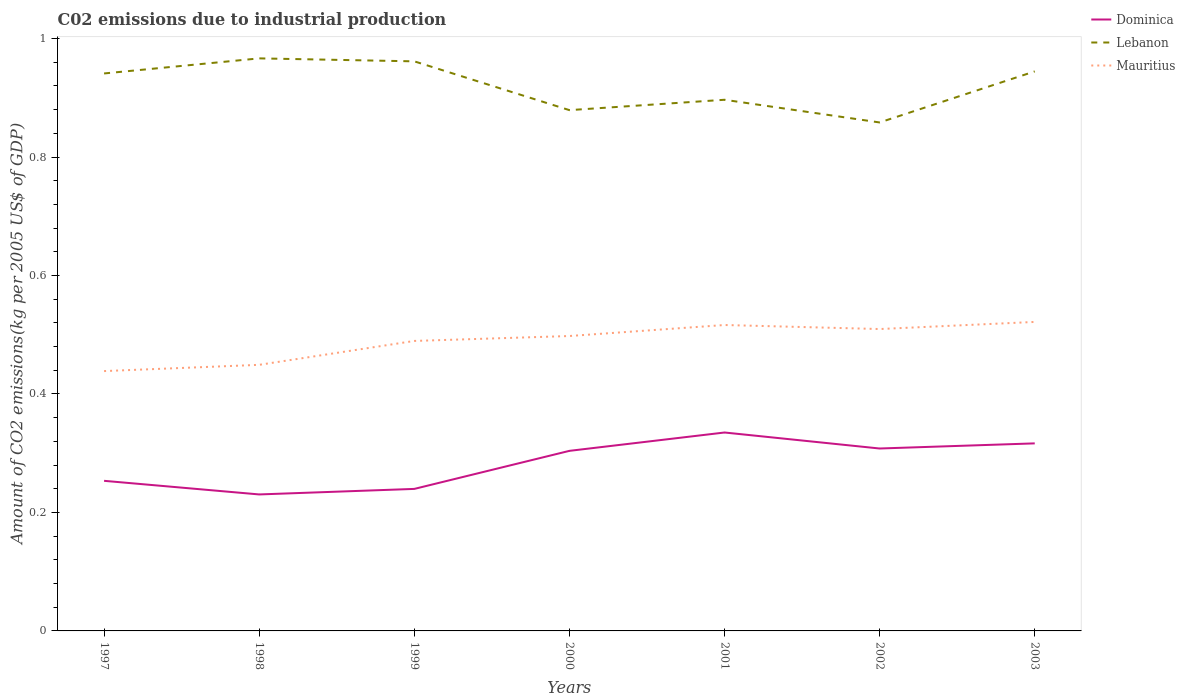How many different coloured lines are there?
Your answer should be compact. 3. Across all years, what is the maximum amount of CO2 emitted due to industrial production in Lebanon?
Ensure brevity in your answer.  0.86. In which year was the amount of CO2 emitted due to industrial production in Lebanon maximum?
Your answer should be compact. 2002. What is the total amount of CO2 emitted due to industrial production in Dominica in the graph?
Give a very brief answer. -0.05. What is the difference between the highest and the second highest amount of CO2 emitted due to industrial production in Mauritius?
Ensure brevity in your answer.  0.08. How many years are there in the graph?
Provide a short and direct response. 7. Are the values on the major ticks of Y-axis written in scientific E-notation?
Your answer should be compact. No. Does the graph contain grids?
Make the answer very short. No. Where does the legend appear in the graph?
Ensure brevity in your answer.  Top right. How are the legend labels stacked?
Provide a short and direct response. Vertical. What is the title of the graph?
Provide a short and direct response. C02 emissions due to industrial production. What is the label or title of the Y-axis?
Your answer should be compact. Amount of CO2 emissions(kg per 2005 US$ of GDP). What is the Amount of CO2 emissions(kg per 2005 US$ of GDP) of Dominica in 1997?
Your answer should be compact. 0.25. What is the Amount of CO2 emissions(kg per 2005 US$ of GDP) in Lebanon in 1997?
Keep it short and to the point. 0.94. What is the Amount of CO2 emissions(kg per 2005 US$ of GDP) of Mauritius in 1997?
Offer a very short reply. 0.44. What is the Amount of CO2 emissions(kg per 2005 US$ of GDP) in Dominica in 1998?
Your answer should be very brief. 0.23. What is the Amount of CO2 emissions(kg per 2005 US$ of GDP) of Lebanon in 1998?
Offer a terse response. 0.97. What is the Amount of CO2 emissions(kg per 2005 US$ of GDP) of Mauritius in 1998?
Offer a very short reply. 0.45. What is the Amount of CO2 emissions(kg per 2005 US$ of GDP) of Dominica in 1999?
Your response must be concise. 0.24. What is the Amount of CO2 emissions(kg per 2005 US$ of GDP) in Lebanon in 1999?
Your answer should be compact. 0.96. What is the Amount of CO2 emissions(kg per 2005 US$ of GDP) in Mauritius in 1999?
Give a very brief answer. 0.49. What is the Amount of CO2 emissions(kg per 2005 US$ of GDP) of Dominica in 2000?
Ensure brevity in your answer.  0.3. What is the Amount of CO2 emissions(kg per 2005 US$ of GDP) in Lebanon in 2000?
Your answer should be compact. 0.88. What is the Amount of CO2 emissions(kg per 2005 US$ of GDP) in Mauritius in 2000?
Your answer should be very brief. 0.5. What is the Amount of CO2 emissions(kg per 2005 US$ of GDP) in Dominica in 2001?
Your response must be concise. 0.33. What is the Amount of CO2 emissions(kg per 2005 US$ of GDP) of Lebanon in 2001?
Make the answer very short. 0.9. What is the Amount of CO2 emissions(kg per 2005 US$ of GDP) of Mauritius in 2001?
Provide a short and direct response. 0.52. What is the Amount of CO2 emissions(kg per 2005 US$ of GDP) of Dominica in 2002?
Ensure brevity in your answer.  0.31. What is the Amount of CO2 emissions(kg per 2005 US$ of GDP) in Lebanon in 2002?
Your response must be concise. 0.86. What is the Amount of CO2 emissions(kg per 2005 US$ of GDP) in Mauritius in 2002?
Give a very brief answer. 0.51. What is the Amount of CO2 emissions(kg per 2005 US$ of GDP) in Dominica in 2003?
Your answer should be compact. 0.32. What is the Amount of CO2 emissions(kg per 2005 US$ of GDP) in Lebanon in 2003?
Provide a short and direct response. 0.94. What is the Amount of CO2 emissions(kg per 2005 US$ of GDP) of Mauritius in 2003?
Provide a succinct answer. 0.52. Across all years, what is the maximum Amount of CO2 emissions(kg per 2005 US$ of GDP) in Dominica?
Provide a succinct answer. 0.33. Across all years, what is the maximum Amount of CO2 emissions(kg per 2005 US$ of GDP) in Lebanon?
Your answer should be compact. 0.97. Across all years, what is the maximum Amount of CO2 emissions(kg per 2005 US$ of GDP) of Mauritius?
Ensure brevity in your answer.  0.52. Across all years, what is the minimum Amount of CO2 emissions(kg per 2005 US$ of GDP) of Dominica?
Keep it short and to the point. 0.23. Across all years, what is the minimum Amount of CO2 emissions(kg per 2005 US$ of GDP) in Lebanon?
Keep it short and to the point. 0.86. Across all years, what is the minimum Amount of CO2 emissions(kg per 2005 US$ of GDP) of Mauritius?
Offer a very short reply. 0.44. What is the total Amount of CO2 emissions(kg per 2005 US$ of GDP) in Dominica in the graph?
Keep it short and to the point. 1.99. What is the total Amount of CO2 emissions(kg per 2005 US$ of GDP) of Lebanon in the graph?
Give a very brief answer. 6.45. What is the total Amount of CO2 emissions(kg per 2005 US$ of GDP) of Mauritius in the graph?
Offer a terse response. 3.42. What is the difference between the Amount of CO2 emissions(kg per 2005 US$ of GDP) in Dominica in 1997 and that in 1998?
Your response must be concise. 0.02. What is the difference between the Amount of CO2 emissions(kg per 2005 US$ of GDP) in Lebanon in 1997 and that in 1998?
Make the answer very short. -0.03. What is the difference between the Amount of CO2 emissions(kg per 2005 US$ of GDP) in Mauritius in 1997 and that in 1998?
Your answer should be very brief. -0.01. What is the difference between the Amount of CO2 emissions(kg per 2005 US$ of GDP) of Dominica in 1997 and that in 1999?
Your answer should be compact. 0.01. What is the difference between the Amount of CO2 emissions(kg per 2005 US$ of GDP) in Lebanon in 1997 and that in 1999?
Offer a terse response. -0.02. What is the difference between the Amount of CO2 emissions(kg per 2005 US$ of GDP) in Mauritius in 1997 and that in 1999?
Provide a short and direct response. -0.05. What is the difference between the Amount of CO2 emissions(kg per 2005 US$ of GDP) in Dominica in 1997 and that in 2000?
Ensure brevity in your answer.  -0.05. What is the difference between the Amount of CO2 emissions(kg per 2005 US$ of GDP) in Lebanon in 1997 and that in 2000?
Your answer should be very brief. 0.06. What is the difference between the Amount of CO2 emissions(kg per 2005 US$ of GDP) in Mauritius in 1997 and that in 2000?
Offer a terse response. -0.06. What is the difference between the Amount of CO2 emissions(kg per 2005 US$ of GDP) of Dominica in 1997 and that in 2001?
Provide a succinct answer. -0.08. What is the difference between the Amount of CO2 emissions(kg per 2005 US$ of GDP) in Lebanon in 1997 and that in 2001?
Your response must be concise. 0.04. What is the difference between the Amount of CO2 emissions(kg per 2005 US$ of GDP) of Mauritius in 1997 and that in 2001?
Ensure brevity in your answer.  -0.08. What is the difference between the Amount of CO2 emissions(kg per 2005 US$ of GDP) in Dominica in 1997 and that in 2002?
Give a very brief answer. -0.05. What is the difference between the Amount of CO2 emissions(kg per 2005 US$ of GDP) in Lebanon in 1997 and that in 2002?
Your response must be concise. 0.08. What is the difference between the Amount of CO2 emissions(kg per 2005 US$ of GDP) of Mauritius in 1997 and that in 2002?
Make the answer very short. -0.07. What is the difference between the Amount of CO2 emissions(kg per 2005 US$ of GDP) in Dominica in 1997 and that in 2003?
Your answer should be very brief. -0.06. What is the difference between the Amount of CO2 emissions(kg per 2005 US$ of GDP) in Lebanon in 1997 and that in 2003?
Ensure brevity in your answer.  -0. What is the difference between the Amount of CO2 emissions(kg per 2005 US$ of GDP) in Mauritius in 1997 and that in 2003?
Make the answer very short. -0.08. What is the difference between the Amount of CO2 emissions(kg per 2005 US$ of GDP) of Dominica in 1998 and that in 1999?
Your answer should be compact. -0.01. What is the difference between the Amount of CO2 emissions(kg per 2005 US$ of GDP) of Lebanon in 1998 and that in 1999?
Keep it short and to the point. 0.01. What is the difference between the Amount of CO2 emissions(kg per 2005 US$ of GDP) in Mauritius in 1998 and that in 1999?
Ensure brevity in your answer.  -0.04. What is the difference between the Amount of CO2 emissions(kg per 2005 US$ of GDP) of Dominica in 1998 and that in 2000?
Your response must be concise. -0.07. What is the difference between the Amount of CO2 emissions(kg per 2005 US$ of GDP) in Lebanon in 1998 and that in 2000?
Offer a very short reply. 0.09. What is the difference between the Amount of CO2 emissions(kg per 2005 US$ of GDP) in Mauritius in 1998 and that in 2000?
Your answer should be compact. -0.05. What is the difference between the Amount of CO2 emissions(kg per 2005 US$ of GDP) of Dominica in 1998 and that in 2001?
Ensure brevity in your answer.  -0.1. What is the difference between the Amount of CO2 emissions(kg per 2005 US$ of GDP) of Lebanon in 1998 and that in 2001?
Your answer should be compact. 0.07. What is the difference between the Amount of CO2 emissions(kg per 2005 US$ of GDP) of Mauritius in 1998 and that in 2001?
Provide a succinct answer. -0.07. What is the difference between the Amount of CO2 emissions(kg per 2005 US$ of GDP) of Dominica in 1998 and that in 2002?
Provide a short and direct response. -0.08. What is the difference between the Amount of CO2 emissions(kg per 2005 US$ of GDP) in Lebanon in 1998 and that in 2002?
Ensure brevity in your answer.  0.11. What is the difference between the Amount of CO2 emissions(kg per 2005 US$ of GDP) of Mauritius in 1998 and that in 2002?
Your answer should be compact. -0.06. What is the difference between the Amount of CO2 emissions(kg per 2005 US$ of GDP) in Dominica in 1998 and that in 2003?
Provide a succinct answer. -0.09. What is the difference between the Amount of CO2 emissions(kg per 2005 US$ of GDP) in Lebanon in 1998 and that in 2003?
Give a very brief answer. 0.02. What is the difference between the Amount of CO2 emissions(kg per 2005 US$ of GDP) in Mauritius in 1998 and that in 2003?
Provide a short and direct response. -0.07. What is the difference between the Amount of CO2 emissions(kg per 2005 US$ of GDP) of Dominica in 1999 and that in 2000?
Make the answer very short. -0.06. What is the difference between the Amount of CO2 emissions(kg per 2005 US$ of GDP) of Lebanon in 1999 and that in 2000?
Offer a very short reply. 0.08. What is the difference between the Amount of CO2 emissions(kg per 2005 US$ of GDP) of Mauritius in 1999 and that in 2000?
Offer a terse response. -0.01. What is the difference between the Amount of CO2 emissions(kg per 2005 US$ of GDP) in Dominica in 1999 and that in 2001?
Provide a short and direct response. -0.1. What is the difference between the Amount of CO2 emissions(kg per 2005 US$ of GDP) of Lebanon in 1999 and that in 2001?
Your answer should be very brief. 0.06. What is the difference between the Amount of CO2 emissions(kg per 2005 US$ of GDP) of Mauritius in 1999 and that in 2001?
Make the answer very short. -0.03. What is the difference between the Amount of CO2 emissions(kg per 2005 US$ of GDP) of Dominica in 1999 and that in 2002?
Your answer should be very brief. -0.07. What is the difference between the Amount of CO2 emissions(kg per 2005 US$ of GDP) of Lebanon in 1999 and that in 2002?
Offer a terse response. 0.1. What is the difference between the Amount of CO2 emissions(kg per 2005 US$ of GDP) of Mauritius in 1999 and that in 2002?
Ensure brevity in your answer.  -0.02. What is the difference between the Amount of CO2 emissions(kg per 2005 US$ of GDP) of Dominica in 1999 and that in 2003?
Give a very brief answer. -0.08. What is the difference between the Amount of CO2 emissions(kg per 2005 US$ of GDP) in Lebanon in 1999 and that in 2003?
Your answer should be compact. 0.02. What is the difference between the Amount of CO2 emissions(kg per 2005 US$ of GDP) in Mauritius in 1999 and that in 2003?
Ensure brevity in your answer.  -0.03. What is the difference between the Amount of CO2 emissions(kg per 2005 US$ of GDP) in Dominica in 2000 and that in 2001?
Make the answer very short. -0.03. What is the difference between the Amount of CO2 emissions(kg per 2005 US$ of GDP) of Lebanon in 2000 and that in 2001?
Your answer should be compact. -0.02. What is the difference between the Amount of CO2 emissions(kg per 2005 US$ of GDP) of Mauritius in 2000 and that in 2001?
Provide a short and direct response. -0.02. What is the difference between the Amount of CO2 emissions(kg per 2005 US$ of GDP) in Dominica in 2000 and that in 2002?
Provide a succinct answer. -0. What is the difference between the Amount of CO2 emissions(kg per 2005 US$ of GDP) in Lebanon in 2000 and that in 2002?
Your response must be concise. 0.02. What is the difference between the Amount of CO2 emissions(kg per 2005 US$ of GDP) of Mauritius in 2000 and that in 2002?
Offer a terse response. -0.01. What is the difference between the Amount of CO2 emissions(kg per 2005 US$ of GDP) in Dominica in 2000 and that in 2003?
Make the answer very short. -0.01. What is the difference between the Amount of CO2 emissions(kg per 2005 US$ of GDP) of Lebanon in 2000 and that in 2003?
Ensure brevity in your answer.  -0.07. What is the difference between the Amount of CO2 emissions(kg per 2005 US$ of GDP) in Mauritius in 2000 and that in 2003?
Your answer should be compact. -0.02. What is the difference between the Amount of CO2 emissions(kg per 2005 US$ of GDP) of Dominica in 2001 and that in 2002?
Your answer should be compact. 0.03. What is the difference between the Amount of CO2 emissions(kg per 2005 US$ of GDP) in Lebanon in 2001 and that in 2002?
Your answer should be very brief. 0.04. What is the difference between the Amount of CO2 emissions(kg per 2005 US$ of GDP) in Mauritius in 2001 and that in 2002?
Keep it short and to the point. 0.01. What is the difference between the Amount of CO2 emissions(kg per 2005 US$ of GDP) in Dominica in 2001 and that in 2003?
Keep it short and to the point. 0.02. What is the difference between the Amount of CO2 emissions(kg per 2005 US$ of GDP) of Lebanon in 2001 and that in 2003?
Provide a succinct answer. -0.05. What is the difference between the Amount of CO2 emissions(kg per 2005 US$ of GDP) of Mauritius in 2001 and that in 2003?
Ensure brevity in your answer.  -0.01. What is the difference between the Amount of CO2 emissions(kg per 2005 US$ of GDP) of Dominica in 2002 and that in 2003?
Offer a very short reply. -0.01. What is the difference between the Amount of CO2 emissions(kg per 2005 US$ of GDP) of Lebanon in 2002 and that in 2003?
Make the answer very short. -0.09. What is the difference between the Amount of CO2 emissions(kg per 2005 US$ of GDP) of Mauritius in 2002 and that in 2003?
Give a very brief answer. -0.01. What is the difference between the Amount of CO2 emissions(kg per 2005 US$ of GDP) of Dominica in 1997 and the Amount of CO2 emissions(kg per 2005 US$ of GDP) of Lebanon in 1998?
Make the answer very short. -0.71. What is the difference between the Amount of CO2 emissions(kg per 2005 US$ of GDP) of Dominica in 1997 and the Amount of CO2 emissions(kg per 2005 US$ of GDP) of Mauritius in 1998?
Provide a succinct answer. -0.2. What is the difference between the Amount of CO2 emissions(kg per 2005 US$ of GDP) in Lebanon in 1997 and the Amount of CO2 emissions(kg per 2005 US$ of GDP) in Mauritius in 1998?
Make the answer very short. 0.49. What is the difference between the Amount of CO2 emissions(kg per 2005 US$ of GDP) of Dominica in 1997 and the Amount of CO2 emissions(kg per 2005 US$ of GDP) of Lebanon in 1999?
Your response must be concise. -0.71. What is the difference between the Amount of CO2 emissions(kg per 2005 US$ of GDP) in Dominica in 1997 and the Amount of CO2 emissions(kg per 2005 US$ of GDP) in Mauritius in 1999?
Your response must be concise. -0.24. What is the difference between the Amount of CO2 emissions(kg per 2005 US$ of GDP) in Lebanon in 1997 and the Amount of CO2 emissions(kg per 2005 US$ of GDP) in Mauritius in 1999?
Offer a terse response. 0.45. What is the difference between the Amount of CO2 emissions(kg per 2005 US$ of GDP) in Dominica in 1997 and the Amount of CO2 emissions(kg per 2005 US$ of GDP) in Lebanon in 2000?
Your answer should be compact. -0.63. What is the difference between the Amount of CO2 emissions(kg per 2005 US$ of GDP) in Dominica in 1997 and the Amount of CO2 emissions(kg per 2005 US$ of GDP) in Mauritius in 2000?
Your answer should be very brief. -0.24. What is the difference between the Amount of CO2 emissions(kg per 2005 US$ of GDP) of Lebanon in 1997 and the Amount of CO2 emissions(kg per 2005 US$ of GDP) of Mauritius in 2000?
Provide a succinct answer. 0.44. What is the difference between the Amount of CO2 emissions(kg per 2005 US$ of GDP) in Dominica in 1997 and the Amount of CO2 emissions(kg per 2005 US$ of GDP) in Lebanon in 2001?
Your answer should be compact. -0.64. What is the difference between the Amount of CO2 emissions(kg per 2005 US$ of GDP) of Dominica in 1997 and the Amount of CO2 emissions(kg per 2005 US$ of GDP) of Mauritius in 2001?
Provide a short and direct response. -0.26. What is the difference between the Amount of CO2 emissions(kg per 2005 US$ of GDP) of Lebanon in 1997 and the Amount of CO2 emissions(kg per 2005 US$ of GDP) of Mauritius in 2001?
Offer a very short reply. 0.42. What is the difference between the Amount of CO2 emissions(kg per 2005 US$ of GDP) of Dominica in 1997 and the Amount of CO2 emissions(kg per 2005 US$ of GDP) of Lebanon in 2002?
Provide a succinct answer. -0.6. What is the difference between the Amount of CO2 emissions(kg per 2005 US$ of GDP) in Dominica in 1997 and the Amount of CO2 emissions(kg per 2005 US$ of GDP) in Mauritius in 2002?
Give a very brief answer. -0.26. What is the difference between the Amount of CO2 emissions(kg per 2005 US$ of GDP) of Lebanon in 1997 and the Amount of CO2 emissions(kg per 2005 US$ of GDP) of Mauritius in 2002?
Your response must be concise. 0.43. What is the difference between the Amount of CO2 emissions(kg per 2005 US$ of GDP) of Dominica in 1997 and the Amount of CO2 emissions(kg per 2005 US$ of GDP) of Lebanon in 2003?
Keep it short and to the point. -0.69. What is the difference between the Amount of CO2 emissions(kg per 2005 US$ of GDP) of Dominica in 1997 and the Amount of CO2 emissions(kg per 2005 US$ of GDP) of Mauritius in 2003?
Offer a terse response. -0.27. What is the difference between the Amount of CO2 emissions(kg per 2005 US$ of GDP) of Lebanon in 1997 and the Amount of CO2 emissions(kg per 2005 US$ of GDP) of Mauritius in 2003?
Keep it short and to the point. 0.42. What is the difference between the Amount of CO2 emissions(kg per 2005 US$ of GDP) in Dominica in 1998 and the Amount of CO2 emissions(kg per 2005 US$ of GDP) in Lebanon in 1999?
Ensure brevity in your answer.  -0.73. What is the difference between the Amount of CO2 emissions(kg per 2005 US$ of GDP) of Dominica in 1998 and the Amount of CO2 emissions(kg per 2005 US$ of GDP) of Mauritius in 1999?
Offer a terse response. -0.26. What is the difference between the Amount of CO2 emissions(kg per 2005 US$ of GDP) of Lebanon in 1998 and the Amount of CO2 emissions(kg per 2005 US$ of GDP) of Mauritius in 1999?
Keep it short and to the point. 0.48. What is the difference between the Amount of CO2 emissions(kg per 2005 US$ of GDP) of Dominica in 1998 and the Amount of CO2 emissions(kg per 2005 US$ of GDP) of Lebanon in 2000?
Make the answer very short. -0.65. What is the difference between the Amount of CO2 emissions(kg per 2005 US$ of GDP) in Dominica in 1998 and the Amount of CO2 emissions(kg per 2005 US$ of GDP) in Mauritius in 2000?
Your response must be concise. -0.27. What is the difference between the Amount of CO2 emissions(kg per 2005 US$ of GDP) of Lebanon in 1998 and the Amount of CO2 emissions(kg per 2005 US$ of GDP) of Mauritius in 2000?
Make the answer very short. 0.47. What is the difference between the Amount of CO2 emissions(kg per 2005 US$ of GDP) in Dominica in 1998 and the Amount of CO2 emissions(kg per 2005 US$ of GDP) in Lebanon in 2001?
Offer a terse response. -0.67. What is the difference between the Amount of CO2 emissions(kg per 2005 US$ of GDP) in Dominica in 1998 and the Amount of CO2 emissions(kg per 2005 US$ of GDP) in Mauritius in 2001?
Your answer should be very brief. -0.29. What is the difference between the Amount of CO2 emissions(kg per 2005 US$ of GDP) of Lebanon in 1998 and the Amount of CO2 emissions(kg per 2005 US$ of GDP) of Mauritius in 2001?
Provide a short and direct response. 0.45. What is the difference between the Amount of CO2 emissions(kg per 2005 US$ of GDP) of Dominica in 1998 and the Amount of CO2 emissions(kg per 2005 US$ of GDP) of Lebanon in 2002?
Ensure brevity in your answer.  -0.63. What is the difference between the Amount of CO2 emissions(kg per 2005 US$ of GDP) in Dominica in 1998 and the Amount of CO2 emissions(kg per 2005 US$ of GDP) in Mauritius in 2002?
Your response must be concise. -0.28. What is the difference between the Amount of CO2 emissions(kg per 2005 US$ of GDP) of Lebanon in 1998 and the Amount of CO2 emissions(kg per 2005 US$ of GDP) of Mauritius in 2002?
Provide a succinct answer. 0.46. What is the difference between the Amount of CO2 emissions(kg per 2005 US$ of GDP) of Dominica in 1998 and the Amount of CO2 emissions(kg per 2005 US$ of GDP) of Lebanon in 2003?
Provide a short and direct response. -0.71. What is the difference between the Amount of CO2 emissions(kg per 2005 US$ of GDP) in Dominica in 1998 and the Amount of CO2 emissions(kg per 2005 US$ of GDP) in Mauritius in 2003?
Keep it short and to the point. -0.29. What is the difference between the Amount of CO2 emissions(kg per 2005 US$ of GDP) in Lebanon in 1998 and the Amount of CO2 emissions(kg per 2005 US$ of GDP) in Mauritius in 2003?
Ensure brevity in your answer.  0.44. What is the difference between the Amount of CO2 emissions(kg per 2005 US$ of GDP) in Dominica in 1999 and the Amount of CO2 emissions(kg per 2005 US$ of GDP) in Lebanon in 2000?
Your answer should be compact. -0.64. What is the difference between the Amount of CO2 emissions(kg per 2005 US$ of GDP) of Dominica in 1999 and the Amount of CO2 emissions(kg per 2005 US$ of GDP) of Mauritius in 2000?
Provide a short and direct response. -0.26. What is the difference between the Amount of CO2 emissions(kg per 2005 US$ of GDP) of Lebanon in 1999 and the Amount of CO2 emissions(kg per 2005 US$ of GDP) of Mauritius in 2000?
Your answer should be very brief. 0.46. What is the difference between the Amount of CO2 emissions(kg per 2005 US$ of GDP) in Dominica in 1999 and the Amount of CO2 emissions(kg per 2005 US$ of GDP) in Lebanon in 2001?
Offer a very short reply. -0.66. What is the difference between the Amount of CO2 emissions(kg per 2005 US$ of GDP) in Dominica in 1999 and the Amount of CO2 emissions(kg per 2005 US$ of GDP) in Mauritius in 2001?
Keep it short and to the point. -0.28. What is the difference between the Amount of CO2 emissions(kg per 2005 US$ of GDP) in Lebanon in 1999 and the Amount of CO2 emissions(kg per 2005 US$ of GDP) in Mauritius in 2001?
Offer a terse response. 0.45. What is the difference between the Amount of CO2 emissions(kg per 2005 US$ of GDP) of Dominica in 1999 and the Amount of CO2 emissions(kg per 2005 US$ of GDP) of Lebanon in 2002?
Make the answer very short. -0.62. What is the difference between the Amount of CO2 emissions(kg per 2005 US$ of GDP) in Dominica in 1999 and the Amount of CO2 emissions(kg per 2005 US$ of GDP) in Mauritius in 2002?
Keep it short and to the point. -0.27. What is the difference between the Amount of CO2 emissions(kg per 2005 US$ of GDP) in Lebanon in 1999 and the Amount of CO2 emissions(kg per 2005 US$ of GDP) in Mauritius in 2002?
Offer a terse response. 0.45. What is the difference between the Amount of CO2 emissions(kg per 2005 US$ of GDP) of Dominica in 1999 and the Amount of CO2 emissions(kg per 2005 US$ of GDP) of Lebanon in 2003?
Your answer should be compact. -0.7. What is the difference between the Amount of CO2 emissions(kg per 2005 US$ of GDP) of Dominica in 1999 and the Amount of CO2 emissions(kg per 2005 US$ of GDP) of Mauritius in 2003?
Your response must be concise. -0.28. What is the difference between the Amount of CO2 emissions(kg per 2005 US$ of GDP) of Lebanon in 1999 and the Amount of CO2 emissions(kg per 2005 US$ of GDP) of Mauritius in 2003?
Give a very brief answer. 0.44. What is the difference between the Amount of CO2 emissions(kg per 2005 US$ of GDP) in Dominica in 2000 and the Amount of CO2 emissions(kg per 2005 US$ of GDP) in Lebanon in 2001?
Make the answer very short. -0.59. What is the difference between the Amount of CO2 emissions(kg per 2005 US$ of GDP) in Dominica in 2000 and the Amount of CO2 emissions(kg per 2005 US$ of GDP) in Mauritius in 2001?
Offer a very short reply. -0.21. What is the difference between the Amount of CO2 emissions(kg per 2005 US$ of GDP) of Lebanon in 2000 and the Amount of CO2 emissions(kg per 2005 US$ of GDP) of Mauritius in 2001?
Give a very brief answer. 0.36. What is the difference between the Amount of CO2 emissions(kg per 2005 US$ of GDP) of Dominica in 2000 and the Amount of CO2 emissions(kg per 2005 US$ of GDP) of Lebanon in 2002?
Your answer should be very brief. -0.55. What is the difference between the Amount of CO2 emissions(kg per 2005 US$ of GDP) of Dominica in 2000 and the Amount of CO2 emissions(kg per 2005 US$ of GDP) of Mauritius in 2002?
Your answer should be compact. -0.21. What is the difference between the Amount of CO2 emissions(kg per 2005 US$ of GDP) of Lebanon in 2000 and the Amount of CO2 emissions(kg per 2005 US$ of GDP) of Mauritius in 2002?
Give a very brief answer. 0.37. What is the difference between the Amount of CO2 emissions(kg per 2005 US$ of GDP) of Dominica in 2000 and the Amount of CO2 emissions(kg per 2005 US$ of GDP) of Lebanon in 2003?
Your answer should be compact. -0.64. What is the difference between the Amount of CO2 emissions(kg per 2005 US$ of GDP) of Dominica in 2000 and the Amount of CO2 emissions(kg per 2005 US$ of GDP) of Mauritius in 2003?
Keep it short and to the point. -0.22. What is the difference between the Amount of CO2 emissions(kg per 2005 US$ of GDP) of Lebanon in 2000 and the Amount of CO2 emissions(kg per 2005 US$ of GDP) of Mauritius in 2003?
Provide a short and direct response. 0.36. What is the difference between the Amount of CO2 emissions(kg per 2005 US$ of GDP) of Dominica in 2001 and the Amount of CO2 emissions(kg per 2005 US$ of GDP) of Lebanon in 2002?
Make the answer very short. -0.52. What is the difference between the Amount of CO2 emissions(kg per 2005 US$ of GDP) of Dominica in 2001 and the Amount of CO2 emissions(kg per 2005 US$ of GDP) of Mauritius in 2002?
Ensure brevity in your answer.  -0.17. What is the difference between the Amount of CO2 emissions(kg per 2005 US$ of GDP) in Lebanon in 2001 and the Amount of CO2 emissions(kg per 2005 US$ of GDP) in Mauritius in 2002?
Provide a short and direct response. 0.39. What is the difference between the Amount of CO2 emissions(kg per 2005 US$ of GDP) in Dominica in 2001 and the Amount of CO2 emissions(kg per 2005 US$ of GDP) in Lebanon in 2003?
Your response must be concise. -0.61. What is the difference between the Amount of CO2 emissions(kg per 2005 US$ of GDP) in Dominica in 2001 and the Amount of CO2 emissions(kg per 2005 US$ of GDP) in Mauritius in 2003?
Ensure brevity in your answer.  -0.19. What is the difference between the Amount of CO2 emissions(kg per 2005 US$ of GDP) of Lebanon in 2001 and the Amount of CO2 emissions(kg per 2005 US$ of GDP) of Mauritius in 2003?
Ensure brevity in your answer.  0.38. What is the difference between the Amount of CO2 emissions(kg per 2005 US$ of GDP) of Dominica in 2002 and the Amount of CO2 emissions(kg per 2005 US$ of GDP) of Lebanon in 2003?
Ensure brevity in your answer.  -0.64. What is the difference between the Amount of CO2 emissions(kg per 2005 US$ of GDP) in Dominica in 2002 and the Amount of CO2 emissions(kg per 2005 US$ of GDP) in Mauritius in 2003?
Give a very brief answer. -0.21. What is the difference between the Amount of CO2 emissions(kg per 2005 US$ of GDP) of Lebanon in 2002 and the Amount of CO2 emissions(kg per 2005 US$ of GDP) of Mauritius in 2003?
Give a very brief answer. 0.34. What is the average Amount of CO2 emissions(kg per 2005 US$ of GDP) in Dominica per year?
Keep it short and to the point. 0.28. What is the average Amount of CO2 emissions(kg per 2005 US$ of GDP) of Lebanon per year?
Keep it short and to the point. 0.92. What is the average Amount of CO2 emissions(kg per 2005 US$ of GDP) in Mauritius per year?
Your answer should be very brief. 0.49. In the year 1997, what is the difference between the Amount of CO2 emissions(kg per 2005 US$ of GDP) of Dominica and Amount of CO2 emissions(kg per 2005 US$ of GDP) of Lebanon?
Provide a succinct answer. -0.69. In the year 1997, what is the difference between the Amount of CO2 emissions(kg per 2005 US$ of GDP) of Dominica and Amount of CO2 emissions(kg per 2005 US$ of GDP) of Mauritius?
Provide a succinct answer. -0.19. In the year 1997, what is the difference between the Amount of CO2 emissions(kg per 2005 US$ of GDP) in Lebanon and Amount of CO2 emissions(kg per 2005 US$ of GDP) in Mauritius?
Provide a succinct answer. 0.5. In the year 1998, what is the difference between the Amount of CO2 emissions(kg per 2005 US$ of GDP) of Dominica and Amount of CO2 emissions(kg per 2005 US$ of GDP) of Lebanon?
Your answer should be very brief. -0.74. In the year 1998, what is the difference between the Amount of CO2 emissions(kg per 2005 US$ of GDP) in Dominica and Amount of CO2 emissions(kg per 2005 US$ of GDP) in Mauritius?
Your response must be concise. -0.22. In the year 1998, what is the difference between the Amount of CO2 emissions(kg per 2005 US$ of GDP) in Lebanon and Amount of CO2 emissions(kg per 2005 US$ of GDP) in Mauritius?
Your response must be concise. 0.52. In the year 1999, what is the difference between the Amount of CO2 emissions(kg per 2005 US$ of GDP) of Dominica and Amount of CO2 emissions(kg per 2005 US$ of GDP) of Lebanon?
Offer a very short reply. -0.72. In the year 1999, what is the difference between the Amount of CO2 emissions(kg per 2005 US$ of GDP) of Dominica and Amount of CO2 emissions(kg per 2005 US$ of GDP) of Mauritius?
Provide a short and direct response. -0.25. In the year 1999, what is the difference between the Amount of CO2 emissions(kg per 2005 US$ of GDP) of Lebanon and Amount of CO2 emissions(kg per 2005 US$ of GDP) of Mauritius?
Your answer should be very brief. 0.47. In the year 2000, what is the difference between the Amount of CO2 emissions(kg per 2005 US$ of GDP) in Dominica and Amount of CO2 emissions(kg per 2005 US$ of GDP) in Lebanon?
Give a very brief answer. -0.58. In the year 2000, what is the difference between the Amount of CO2 emissions(kg per 2005 US$ of GDP) in Dominica and Amount of CO2 emissions(kg per 2005 US$ of GDP) in Mauritius?
Offer a terse response. -0.19. In the year 2000, what is the difference between the Amount of CO2 emissions(kg per 2005 US$ of GDP) of Lebanon and Amount of CO2 emissions(kg per 2005 US$ of GDP) of Mauritius?
Provide a succinct answer. 0.38. In the year 2001, what is the difference between the Amount of CO2 emissions(kg per 2005 US$ of GDP) of Dominica and Amount of CO2 emissions(kg per 2005 US$ of GDP) of Lebanon?
Your response must be concise. -0.56. In the year 2001, what is the difference between the Amount of CO2 emissions(kg per 2005 US$ of GDP) of Dominica and Amount of CO2 emissions(kg per 2005 US$ of GDP) of Mauritius?
Provide a succinct answer. -0.18. In the year 2001, what is the difference between the Amount of CO2 emissions(kg per 2005 US$ of GDP) of Lebanon and Amount of CO2 emissions(kg per 2005 US$ of GDP) of Mauritius?
Give a very brief answer. 0.38. In the year 2002, what is the difference between the Amount of CO2 emissions(kg per 2005 US$ of GDP) of Dominica and Amount of CO2 emissions(kg per 2005 US$ of GDP) of Lebanon?
Offer a very short reply. -0.55. In the year 2002, what is the difference between the Amount of CO2 emissions(kg per 2005 US$ of GDP) in Dominica and Amount of CO2 emissions(kg per 2005 US$ of GDP) in Mauritius?
Make the answer very short. -0.2. In the year 2002, what is the difference between the Amount of CO2 emissions(kg per 2005 US$ of GDP) in Lebanon and Amount of CO2 emissions(kg per 2005 US$ of GDP) in Mauritius?
Provide a short and direct response. 0.35. In the year 2003, what is the difference between the Amount of CO2 emissions(kg per 2005 US$ of GDP) of Dominica and Amount of CO2 emissions(kg per 2005 US$ of GDP) of Lebanon?
Give a very brief answer. -0.63. In the year 2003, what is the difference between the Amount of CO2 emissions(kg per 2005 US$ of GDP) of Dominica and Amount of CO2 emissions(kg per 2005 US$ of GDP) of Mauritius?
Offer a terse response. -0.2. In the year 2003, what is the difference between the Amount of CO2 emissions(kg per 2005 US$ of GDP) in Lebanon and Amount of CO2 emissions(kg per 2005 US$ of GDP) in Mauritius?
Your answer should be very brief. 0.42. What is the ratio of the Amount of CO2 emissions(kg per 2005 US$ of GDP) in Dominica in 1997 to that in 1998?
Give a very brief answer. 1.1. What is the ratio of the Amount of CO2 emissions(kg per 2005 US$ of GDP) in Lebanon in 1997 to that in 1998?
Ensure brevity in your answer.  0.97. What is the ratio of the Amount of CO2 emissions(kg per 2005 US$ of GDP) of Mauritius in 1997 to that in 1998?
Your answer should be compact. 0.98. What is the ratio of the Amount of CO2 emissions(kg per 2005 US$ of GDP) of Dominica in 1997 to that in 1999?
Your answer should be compact. 1.06. What is the ratio of the Amount of CO2 emissions(kg per 2005 US$ of GDP) of Lebanon in 1997 to that in 1999?
Offer a terse response. 0.98. What is the ratio of the Amount of CO2 emissions(kg per 2005 US$ of GDP) of Mauritius in 1997 to that in 1999?
Offer a terse response. 0.9. What is the ratio of the Amount of CO2 emissions(kg per 2005 US$ of GDP) in Dominica in 1997 to that in 2000?
Your answer should be compact. 0.83. What is the ratio of the Amount of CO2 emissions(kg per 2005 US$ of GDP) of Lebanon in 1997 to that in 2000?
Keep it short and to the point. 1.07. What is the ratio of the Amount of CO2 emissions(kg per 2005 US$ of GDP) in Mauritius in 1997 to that in 2000?
Your response must be concise. 0.88. What is the ratio of the Amount of CO2 emissions(kg per 2005 US$ of GDP) of Dominica in 1997 to that in 2001?
Your response must be concise. 0.76. What is the ratio of the Amount of CO2 emissions(kg per 2005 US$ of GDP) in Lebanon in 1997 to that in 2001?
Offer a very short reply. 1.05. What is the ratio of the Amount of CO2 emissions(kg per 2005 US$ of GDP) of Mauritius in 1997 to that in 2001?
Your response must be concise. 0.85. What is the ratio of the Amount of CO2 emissions(kg per 2005 US$ of GDP) in Dominica in 1997 to that in 2002?
Your answer should be compact. 0.82. What is the ratio of the Amount of CO2 emissions(kg per 2005 US$ of GDP) in Lebanon in 1997 to that in 2002?
Keep it short and to the point. 1.1. What is the ratio of the Amount of CO2 emissions(kg per 2005 US$ of GDP) in Mauritius in 1997 to that in 2002?
Make the answer very short. 0.86. What is the ratio of the Amount of CO2 emissions(kg per 2005 US$ of GDP) of Dominica in 1997 to that in 2003?
Provide a succinct answer. 0.8. What is the ratio of the Amount of CO2 emissions(kg per 2005 US$ of GDP) of Lebanon in 1997 to that in 2003?
Provide a short and direct response. 1. What is the ratio of the Amount of CO2 emissions(kg per 2005 US$ of GDP) of Mauritius in 1997 to that in 2003?
Your answer should be compact. 0.84. What is the ratio of the Amount of CO2 emissions(kg per 2005 US$ of GDP) in Dominica in 1998 to that in 1999?
Give a very brief answer. 0.96. What is the ratio of the Amount of CO2 emissions(kg per 2005 US$ of GDP) in Lebanon in 1998 to that in 1999?
Provide a succinct answer. 1.01. What is the ratio of the Amount of CO2 emissions(kg per 2005 US$ of GDP) in Mauritius in 1998 to that in 1999?
Make the answer very short. 0.92. What is the ratio of the Amount of CO2 emissions(kg per 2005 US$ of GDP) in Dominica in 1998 to that in 2000?
Offer a terse response. 0.76. What is the ratio of the Amount of CO2 emissions(kg per 2005 US$ of GDP) in Lebanon in 1998 to that in 2000?
Give a very brief answer. 1.1. What is the ratio of the Amount of CO2 emissions(kg per 2005 US$ of GDP) in Mauritius in 1998 to that in 2000?
Your answer should be very brief. 0.9. What is the ratio of the Amount of CO2 emissions(kg per 2005 US$ of GDP) in Dominica in 1998 to that in 2001?
Offer a very short reply. 0.69. What is the ratio of the Amount of CO2 emissions(kg per 2005 US$ of GDP) in Lebanon in 1998 to that in 2001?
Your response must be concise. 1.08. What is the ratio of the Amount of CO2 emissions(kg per 2005 US$ of GDP) of Mauritius in 1998 to that in 2001?
Offer a terse response. 0.87. What is the ratio of the Amount of CO2 emissions(kg per 2005 US$ of GDP) of Dominica in 1998 to that in 2002?
Your response must be concise. 0.75. What is the ratio of the Amount of CO2 emissions(kg per 2005 US$ of GDP) in Lebanon in 1998 to that in 2002?
Ensure brevity in your answer.  1.13. What is the ratio of the Amount of CO2 emissions(kg per 2005 US$ of GDP) of Mauritius in 1998 to that in 2002?
Keep it short and to the point. 0.88. What is the ratio of the Amount of CO2 emissions(kg per 2005 US$ of GDP) in Dominica in 1998 to that in 2003?
Your answer should be very brief. 0.73. What is the ratio of the Amount of CO2 emissions(kg per 2005 US$ of GDP) of Lebanon in 1998 to that in 2003?
Your answer should be very brief. 1.02. What is the ratio of the Amount of CO2 emissions(kg per 2005 US$ of GDP) in Mauritius in 1998 to that in 2003?
Ensure brevity in your answer.  0.86. What is the ratio of the Amount of CO2 emissions(kg per 2005 US$ of GDP) in Dominica in 1999 to that in 2000?
Your answer should be compact. 0.79. What is the ratio of the Amount of CO2 emissions(kg per 2005 US$ of GDP) of Lebanon in 1999 to that in 2000?
Your response must be concise. 1.09. What is the ratio of the Amount of CO2 emissions(kg per 2005 US$ of GDP) of Mauritius in 1999 to that in 2000?
Offer a very short reply. 0.98. What is the ratio of the Amount of CO2 emissions(kg per 2005 US$ of GDP) of Dominica in 1999 to that in 2001?
Your response must be concise. 0.72. What is the ratio of the Amount of CO2 emissions(kg per 2005 US$ of GDP) of Lebanon in 1999 to that in 2001?
Ensure brevity in your answer.  1.07. What is the ratio of the Amount of CO2 emissions(kg per 2005 US$ of GDP) of Mauritius in 1999 to that in 2001?
Ensure brevity in your answer.  0.95. What is the ratio of the Amount of CO2 emissions(kg per 2005 US$ of GDP) in Dominica in 1999 to that in 2002?
Provide a short and direct response. 0.78. What is the ratio of the Amount of CO2 emissions(kg per 2005 US$ of GDP) in Lebanon in 1999 to that in 2002?
Offer a very short reply. 1.12. What is the ratio of the Amount of CO2 emissions(kg per 2005 US$ of GDP) of Mauritius in 1999 to that in 2002?
Your answer should be very brief. 0.96. What is the ratio of the Amount of CO2 emissions(kg per 2005 US$ of GDP) of Dominica in 1999 to that in 2003?
Offer a very short reply. 0.76. What is the ratio of the Amount of CO2 emissions(kg per 2005 US$ of GDP) in Lebanon in 1999 to that in 2003?
Give a very brief answer. 1.02. What is the ratio of the Amount of CO2 emissions(kg per 2005 US$ of GDP) in Mauritius in 1999 to that in 2003?
Your response must be concise. 0.94. What is the ratio of the Amount of CO2 emissions(kg per 2005 US$ of GDP) of Dominica in 2000 to that in 2001?
Provide a short and direct response. 0.91. What is the ratio of the Amount of CO2 emissions(kg per 2005 US$ of GDP) of Lebanon in 2000 to that in 2001?
Your answer should be compact. 0.98. What is the ratio of the Amount of CO2 emissions(kg per 2005 US$ of GDP) of Mauritius in 2000 to that in 2001?
Make the answer very short. 0.96. What is the ratio of the Amount of CO2 emissions(kg per 2005 US$ of GDP) of Dominica in 2000 to that in 2002?
Provide a short and direct response. 0.99. What is the ratio of the Amount of CO2 emissions(kg per 2005 US$ of GDP) of Lebanon in 2000 to that in 2002?
Provide a succinct answer. 1.02. What is the ratio of the Amount of CO2 emissions(kg per 2005 US$ of GDP) of Mauritius in 2000 to that in 2002?
Provide a short and direct response. 0.98. What is the ratio of the Amount of CO2 emissions(kg per 2005 US$ of GDP) in Dominica in 2000 to that in 2003?
Your answer should be compact. 0.96. What is the ratio of the Amount of CO2 emissions(kg per 2005 US$ of GDP) of Lebanon in 2000 to that in 2003?
Keep it short and to the point. 0.93. What is the ratio of the Amount of CO2 emissions(kg per 2005 US$ of GDP) in Mauritius in 2000 to that in 2003?
Make the answer very short. 0.95. What is the ratio of the Amount of CO2 emissions(kg per 2005 US$ of GDP) in Dominica in 2001 to that in 2002?
Ensure brevity in your answer.  1.09. What is the ratio of the Amount of CO2 emissions(kg per 2005 US$ of GDP) of Lebanon in 2001 to that in 2002?
Provide a succinct answer. 1.04. What is the ratio of the Amount of CO2 emissions(kg per 2005 US$ of GDP) in Mauritius in 2001 to that in 2002?
Provide a short and direct response. 1.01. What is the ratio of the Amount of CO2 emissions(kg per 2005 US$ of GDP) of Dominica in 2001 to that in 2003?
Your answer should be very brief. 1.06. What is the ratio of the Amount of CO2 emissions(kg per 2005 US$ of GDP) in Lebanon in 2001 to that in 2003?
Keep it short and to the point. 0.95. What is the ratio of the Amount of CO2 emissions(kg per 2005 US$ of GDP) of Dominica in 2002 to that in 2003?
Your answer should be very brief. 0.97. What is the ratio of the Amount of CO2 emissions(kg per 2005 US$ of GDP) in Lebanon in 2002 to that in 2003?
Your answer should be very brief. 0.91. What is the difference between the highest and the second highest Amount of CO2 emissions(kg per 2005 US$ of GDP) of Dominica?
Your answer should be very brief. 0.02. What is the difference between the highest and the second highest Amount of CO2 emissions(kg per 2005 US$ of GDP) of Lebanon?
Keep it short and to the point. 0.01. What is the difference between the highest and the second highest Amount of CO2 emissions(kg per 2005 US$ of GDP) in Mauritius?
Offer a very short reply. 0.01. What is the difference between the highest and the lowest Amount of CO2 emissions(kg per 2005 US$ of GDP) in Dominica?
Offer a very short reply. 0.1. What is the difference between the highest and the lowest Amount of CO2 emissions(kg per 2005 US$ of GDP) of Lebanon?
Make the answer very short. 0.11. What is the difference between the highest and the lowest Amount of CO2 emissions(kg per 2005 US$ of GDP) in Mauritius?
Your answer should be compact. 0.08. 